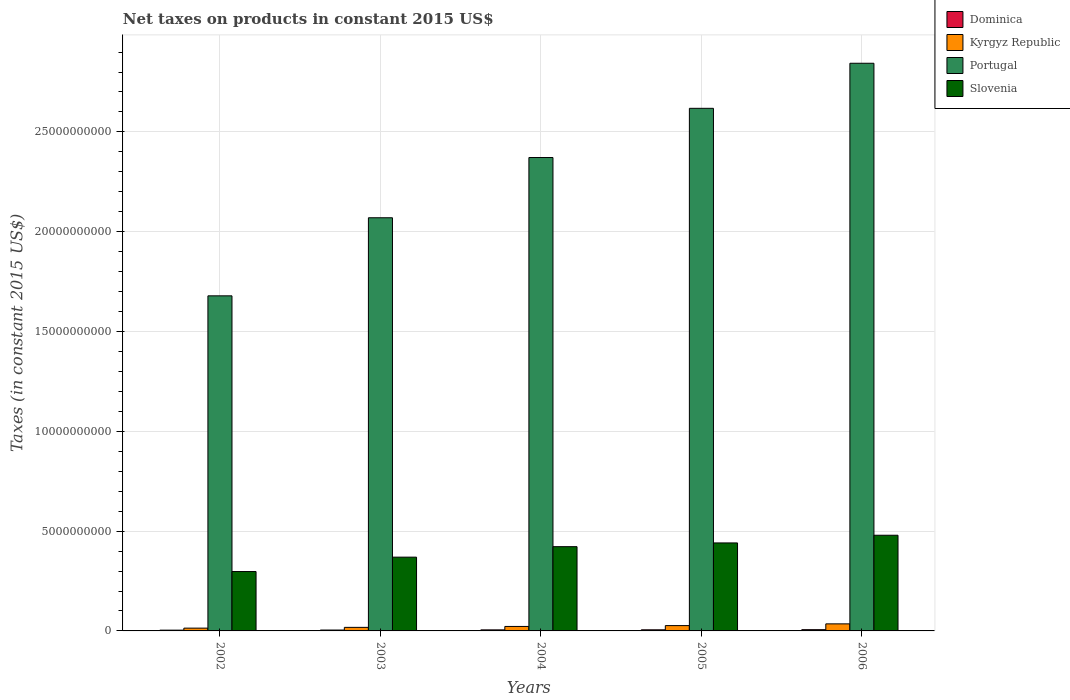How many different coloured bars are there?
Ensure brevity in your answer.  4. Are the number of bars per tick equal to the number of legend labels?
Offer a terse response. Yes. How many bars are there on the 2nd tick from the left?
Make the answer very short. 4. How many bars are there on the 5th tick from the right?
Ensure brevity in your answer.  4. What is the label of the 3rd group of bars from the left?
Your response must be concise. 2004. In how many cases, is the number of bars for a given year not equal to the number of legend labels?
Give a very brief answer. 0. What is the net taxes on products in Dominica in 2004?
Ensure brevity in your answer.  5.27e+07. Across all years, what is the maximum net taxes on products in Portugal?
Ensure brevity in your answer.  2.84e+1. Across all years, what is the minimum net taxes on products in Portugal?
Keep it short and to the point. 1.68e+1. What is the total net taxes on products in Slovenia in the graph?
Provide a succinct answer. 2.01e+1. What is the difference between the net taxes on products in Portugal in 2004 and that in 2005?
Offer a terse response. -2.47e+09. What is the difference between the net taxes on products in Slovenia in 2005 and the net taxes on products in Kyrgyz Republic in 2006?
Provide a short and direct response. 4.05e+09. What is the average net taxes on products in Dominica per year?
Give a very brief answer. 5.09e+07. In the year 2006, what is the difference between the net taxes on products in Dominica and net taxes on products in Slovenia?
Make the answer very short. -4.73e+09. In how many years, is the net taxes on products in Portugal greater than 2000000000 US$?
Offer a terse response. 5. What is the ratio of the net taxes on products in Slovenia in 2003 to that in 2006?
Offer a very short reply. 0.77. Is the net taxes on products in Kyrgyz Republic in 2003 less than that in 2006?
Your answer should be compact. Yes. Is the difference between the net taxes on products in Dominica in 2002 and 2004 greater than the difference between the net taxes on products in Slovenia in 2002 and 2004?
Offer a terse response. Yes. What is the difference between the highest and the second highest net taxes on products in Dominica?
Make the answer very short. 6.94e+06. What is the difference between the highest and the lowest net taxes on products in Dominica?
Give a very brief answer. 2.48e+07. Is the sum of the net taxes on products in Dominica in 2004 and 2005 greater than the maximum net taxes on products in Slovenia across all years?
Offer a terse response. No. What does the 2nd bar from the left in 2004 represents?
Give a very brief answer. Kyrgyz Republic. What does the 2nd bar from the right in 2005 represents?
Your answer should be compact. Portugal. How many bars are there?
Offer a terse response. 20. Are all the bars in the graph horizontal?
Make the answer very short. No. What is the difference between two consecutive major ticks on the Y-axis?
Your answer should be very brief. 5.00e+09. Does the graph contain grids?
Ensure brevity in your answer.  Yes. What is the title of the graph?
Your response must be concise. Net taxes on products in constant 2015 US$. What is the label or title of the X-axis?
Provide a short and direct response. Years. What is the label or title of the Y-axis?
Give a very brief answer. Taxes (in constant 2015 US$). What is the Taxes (in constant 2015 US$) in Dominica in 2002?
Offer a very short reply. 3.84e+07. What is the Taxes (in constant 2015 US$) of Kyrgyz Republic in 2002?
Give a very brief answer. 1.40e+08. What is the Taxes (in constant 2015 US$) of Portugal in 2002?
Make the answer very short. 1.68e+1. What is the Taxes (in constant 2015 US$) of Slovenia in 2002?
Give a very brief answer. 2.98e+09. What is the Taxes (in constant 2015 US$) of Dominica in 2003?
Offer a terse response. 4.41e+07. What is the Taxes (in constant 2015 US$) in Kyrgyz Republic in 2003?
Keep it short and to the point. 1.78e+08. What is the Taxes (in constant 2015 US$) in Portugal in 2003?
Your response must be concise. 2.07e+1. What is the Taxes (in constant 2015 US$) of Slovenia in 2003?
Offer a very short reply. 3.70e+09. What is the Taxes (in constant 2015 US$) of Dominica in 2004?
Offer a terse response. 5.27e+07. What is the Taxes (in constant 2015 US$) of Kyrgyz Republic in 2004?
Your response must be concise. 2.24e+08. What is the Taxes (in constant 2015 US$) of Portugal in 2004?
Your answer should be very brief. 2.37e+1. What is the Taxes (in constant 2015 US$) of Slovenia in 2004?
Give a very brief answer. 4.22e+09. What is the Taxes (in constant 2015 US$) of Dominica in 2005?
Offer a very short reply. 5.63e+07. What is the Taxes (in constant 2015 US$) in Kyrgyz Republic in 2005?
Your answer should be compact. 2.67e+08. What is the Taxes (in constant 2015 US$) of Portugal in 2005?
Give a very brief answer. 2.62e+1. What is the Taxes (in constant 2015 US$) in Slovenia in 2005?
Offer a very short reply. 4.41e+09. What is the Taxes (in constant 2015 US$) of Dominica in 2006?
Provide a short and direct response. 6.32e+07. What is the Taxes (in constant 2015 US$) in Kyrgyz Republic in 2006?
Your answer should be very brief. 3.54e+08. What is the Taxes (in constant 2015 US$) in Portugal in 2006?
Your answer should be compact. 2.84e+1. What is the Taxes (in constant 2015 US$) of Slovenia in 2006?
Your response must be concise. 4.79e+09. Across all years, what is the maximum Taxes (in constant 2015 US$) of Dominica?
Provide a succinct answer. 6.32e+07. Across all years, what is the maximum Taxes (in constant 2015 US$) in Kyrgyz Republic?
Give a very brief answer. 3.54e+08. Across all years, what is the maximum Taxes (in constant 2015 US$) in Portugal?
Offer a very short reply. 2.84e+1. Across all years, what is the maximum Taxes (in constant 2015 US$) of Slovenia?
Offer a terse response. 4.79e+09. Across all years, what is the minimum Taxes (in constant 2015 US$) in Dominica?
Your answer should be very brief. 3.84e+07. Across all years, what is the minimum Taxes (in constant 2015 US$) in Kyrgyz Republic?
Give a very brief answer. 1.40e+08. Across all years, what is the minimum Taxes (in constant 2015 US$) of Portugal?
Ensure brevity in your answer.  1.68e+1. Across all years, what is the minimum Taxes (in constant 2015 US$) of Slovenia?
Offer a very short reply. 2.98e+09. What is the total Taxes (in constant 2015 US$) in Dominica in the graph?
Your response must be concise. 2.55e+08. What is the total Taxes (in constant 2015 US$) in Kyrgyz Republic in the graph?
Offer a very short reply. 1.16e+09. What is the total Taxes (in constant 2015 US$) of Portugal in the graph?
Make the answer very short. 1.16e+11. What is the total Taxes (in constant 2015 US$) in Slovenia in the graph?
Keep it short and to the point. 2.01e+1. What is the difference between the Taxes (in constant 2015 US$) of Dominica in 2002 and that in 2003?
Ensure brevity in your answer.  -5.64e+06. What is the difference between the Taxes (in constant 2015 US$) of Kyrgyz Republic in 2002 and that in 2003?
Offer a terse response. -3.85e+07. What is the difference between the Taxes (in constant 2015 US$) of Portugal in 2002 and that in 2003?
Provide a succinct answer. -3.91e+09. What is the difference between the Taxes (in constant 2015 US$) of Slovenia in 2002 and that in 2003?
Offer a very short reply. -7.21e+08. What is the difference between the Taxes (in constant 2015 US$) in Dominica in 2002 and that in 2004?
Offer a very short reply. -1.43e+07. What is the difference between the Taxes (in constant 2015 US$) in Kyrgyz Republic in 2002 and that in 2004?
Keep it short and to the point. -8.43e+07. What is the difference between the Taxes (in constant 2015 US$) of Portugal in 2002 and that in 2004?
Your response must be concise. -6.93e+09. What is the difference between the Taxes (in constant 2015 US$) in Slovenia in 2002 and that in 2004?
Offer a terse response. -1.25e+09. What is the difference between the Taxes (in constant 2015 US$) in Dominica in 2002 and that in 2005?
Make the answer very short. -1.79e+07. What is the difference between the Taxes (in constant 2015 US$) in Kyrgyz Republic in 2002 and that in 2005?
Your response must be concise. -1.27e+08. What is the difference between the Taxes (in constant 2015 US$) of Portugal in 2002 and that in 2005?
Your answer should be very brief. -9.39e+09. What is the difference between the Taxes (in constant 2015 US$) in Slovenia in 2002 and that in 2005?
Provide a short and direct response. -1.43e+09. What is the difference between the Taxes (in constant 2015 US$) of Dominica in 2002 and that in 2006?
Keep it short and to the point. -2.48e+07. What is the difference between the Taxes (in constant 2015 US$) of Kyrgyz Republic in 2002 and that in 2006?
Provide a short and direct response. -2.14e+08. What is the difference between the Taxes (in constant 2015 US$) in Portugal in 2002 and that in 2006?
Offer a terse response. -1.17e+1. What is the difference between the Taxes (in constant 2015 US$) of Slovenia in 2002 and that in 2006?
Provide a short and direct response. -1.82e+09. What is the difference between the Taxes (in constant 2015 US$) of Dominica in 2003 and that in 2004?
Your answer should be very brief. -8.61e+06. What is the difference between the Taxes (in constant 2015 US$) of Kyrgyz Republic in 2003 and that in 2004?
Make the answer very short. -4.57e+07. What is the difference between the Taxes (in constant 2015 US$) in Portugal in 2003 and that in 2004?
Provide a succinct answer. -3.02e+09. What is the difference between the Taxes (in constant 2015 US$) of Slovenia in 2003 and that in 2004?
Offer a terse response. -5.26e+08. What is the difference between the Taxes (in constant 2015 US$) in Dominica in 2003 and that in 2005?
Keep it short and to the point. -1.22e+07. What is the difference between the Taxes (in constant 2015 US$) in Kyrgyz Republic in 2003 and that in 2005?
Your answer should be compact. -8.84e+07. What is the difference between the Taxes (in constant 2015 US$) of Portugal in 2003 and that in 2005?
Provide a short and direct response. -5.48e+09. What is the difference between the Taxes (in constant 2015 US$) of Slovenia in 2003 and that in 2005?
Give a very brief answer. -7.13e+08. What is the difference between the Taxes (in constant 2015 US$) in Dominica in 2003 and that in 2006?
Give a very brief answer. -1.92e+07. What is the difference between the Taxes (in constant 2015 US$) in Kyrgyz Republic in 2003 and that in 2006?
Your response must be concise. -1.75e+08. What is the difference between the Taxes (in constant 2015 US$) of Portugal in 2003 and that in 2006?
Provide a short and direct response. -7.74e+09. What is the difference between the Taxes (in constant 2015 US$) of Slovenia in 2003 and that in 2006?
Ensure brevity in your answer.  -1.10e+09. What is the difference between the Taxes (in constant 2015 US$) in Dominica in 2004 and that in 2005?
Provide a short and direct response. -3.61e+06. What is the difference between the Taxes (in constant 2015 US$) in Kyrgyz Republic in 2004 and that in 2005?
Keep it short and to the point. -4.27e+07. What is the difference between the Taxes (in constant 2015 US$) of Portugal in 2004 and that in 2005?
Offer a terse response. -2.47e+09. What is the difference between the Taxes (in constant 2015 US$) of Slovenia in 2004 and that in 2005?
Provide a short and direct response. -1.87e+08. What is the difference between the Taxes (in constant 2015 US$) of Dominica in 2004 and that in 2006?
Give a very brief answer. -1.06e+07. What is the difference between the Taxes (in constant 2015 US$) of Kyrgyz Republic in 2004 and that in 2006?
Ensure brevity in your answer.  -1.30e+08. What is the difference between the Taxes (in constant 2015 US$) in Portugal in 2004 and that in 2006?
Provide a succinct answer. -4.72e+09. What is the difference between the Taxes (in constant 2015 US$) in Slovenia in 2004 and that in 2006?
Keep it short and to the point. -5.72e+08. What is the difference between the Taxes (in constant 2015 US$) of Dominica in 2005 and that in 2006?
Your answer should be very brief. -6.94e+06. What is the difference between the Taxes (in constant 2015 US$) in Kyrgyz Republic in 2005 and that in 2006?
Your response must be concise. -8.70e+07. What is the difference between the Taxes (in constant 2015 US$) of Portugal in 2005 and that in 2006?
Provide a short and direct response. -2.26e+09. What is the difference between the Taxes (in constant 2015 US$) of Slovenia in 2005 and that in 2006?
Ensure brevity in your answer.  -3.85e+08. What is the difference between the Taxes (in constant 2015 US$) of Dominica in 2002 and the Taxes (in constant 2015 US$) of Kyrgyz Republic in 2003?
Your answer should be compact. -1.40e+08. What is the difference between the Taxes (in constant 2015 US$) of Dominica in 2002 and the Taxes (in constant 2015 US$) of Portugal in 2003?
Ensure brevity in your answer.  -2.07e+1. What is the difference between the Taxes (in constant 2015 US$) of Dominica in 2002 and the Taxes (in constant 2015 US$) of Slovenia in 2003?
Your answer should be very brief. -3.66e+09. What is the difference between the Taxes (in constant 2015 US$) of Kyrgyz Republic in 2002 and the Taxes (in constant 2015 US$) of Portugal in 2003?
Your response must be concise. -2.06e+1. What is the difference between the Taxes (in constant 2015 US$) of Kyrgyz Republic in 2002 and the Taxes (in constant 2015 US$) of Slovenia in 2003?
Make the answer very short. -3.56e+09. What is the difference between the Taxes (in constant 2015 US$) in Portugal in 2002 and the Taxes (in constant 2015 US$) in Slovenia in 2003?
Your answer should be very brief. 1.31e+1. What is the difference between the Taxes (in constant 2015 US$) of Dominica in 2002 and the Taxes (in constant 2015 US$) of Kyrgyz Republic in 2004?
Give a very brief answer. -1.85e+08. What is the difference between the Taxes (in constant 2015 US$) of Dominica in 2002 and the Taxes (in constant 2015 US$) of Portugal in 2004?
Ensure brevity in your answer.  -2.37e+1. What is the difference between the Taxes (in constant 2015 US$) of Dominica in 2002 and the Taxes (in constant 2015 US$) of Slovenia in 2004?
Keep it short and to the point. -4.18e+09. What is the difference between the Taxes (in constant 2015 US$) in Kyrgyz Republic in 2002 and the Taxes (in constant 2015 US$) in Portugal in 2004?
Ensure brevity in your answer.  -2.36e+1. What is the difference between the Taxes (in constant 2015 US$) in Kyrgyz Republic in 2002 and the Taxes (in constant 2015 US$) in Slovenia in 2004?
Ensure brevity in your answer.  -4.08e+09. What is the difference between the Taxes (in constant 2015 US$) in Portugal in 2002 and the Taxes (in constant 2015 US$) in Slovenia in 2004?
Provide a short and direct response. 1.26e+1. What is the difference between the Taxes (in constant 2015 US$) in Dominica in 2002 and the Taxes (in constant 2015 US$) in Kyrgyz Republic in 2005?
Your answer should be very brief. -2.28e+08. What is the difference between the Taxes (in constant 2015 US$) of Dominica in 2002 and the Taxes (in constant 2015 US$) of Portugal in 2005?
Offer a terse response. -2.61e+1. What is the difference between the Taxes (in constant 2015 US$) in Dominica in 2002 and the Taxes (in constant 2015 US$) in Slovenia in 2005?
Your answer should be compact. -4.37e+09. What is the difference between the Taxes (in constant 2015 US$) in Kyrgyz Republic in 2002 and the Taxes (in constant 2015 US$) in Portugal in 2005?
Ensure brevity in your answer.  -2.60e+1. What is the difference between the Taxes (in constant 2015 US$) of Kyrgyz Republic in 2002 and the Taxes (in constant 2015 US$) of Slovenia in 2005?
Keep it short and to the point. -4.27e+09. What is the difference between the Taxes (in constant 2015 US$) of Portugal in 2002 and the Taxes (in constant 2015 US$) of Slovenia in 2005?
Your answer should be compact. 1.24e+1. What is the difference between the Taxes (in constant 2015 US$) of Dominica in 2002 and the Taxes (in constant 2015 US$) of Kyrgyz Republic in 2006?
Offer a very short reply. -3.15e+08. What is the difference between the Taxes (in constant 2015 US$) of Dominica in 2002 and the Taxes (in constant 2015 US$) of Portugal in 2006?
Your answer should be very brief. -2.84e+1. What is the difference between the Taxes (in constant 2015 US$) in Dominica in 2002 and the Taxes (in constant 2015 US$) in Slovenia in 2006?
Your answer should be very brief. -4.75e+09. What is the difference between the Taxes (in constant 2015 US$) in Kyrgyz Republic in 2002 and the Taxes (in constant 2015 US$) in Portugal in 2006?
Your response must be concise. -2.83e+1. What is the difference between the Taxes (in constant 2015 US$) of Kyrgyz Republic in 2002 and the Taxes (in constant 2015 US$) of Slovenia in 2006?
Offer a very short reply. -4.65e+09. What is the difference between the Taxes (in constant 2015 US$) of Portugal in 2002 and the Taxes (in constant 2015 US$) of Slovenia in 2006?
Offer a terse response. 1.20e+1. What is the difference between the Taxes (in constant 2015 US$) of Dominica in 2003 and the Taxes (in constant 2015 US$) of Kyrgyz Republic in 2004?
Offer a terse response. -1.80e+08. What is the difference between the Taxes (in constant 2015 US$) in Dominica in 2003 and the Taxes (in constant 2015 US$) in Portugal in 2004?
Your answer should be compact. -2.37e+1. What is the difference between the Taxes (in constant 2015 US$) of Dominica in 2003 and the Taxes (in constant 2015 US$) of Slovenia in 2004?
Your answer should be compact. -4.18e+09. What is the difference between the Taxes (in constant 2015 US$) of Kyrgyz Republic in 2003 and the Taxes (in constant 2015 US$) of Portugal in 2004?
Ensure brevity in your answer.  -2.35e+1. What is the difference between the Taxes (in constant 2015 US$) in Kyrgyz Republic in 2003 and the Taxes (in constant 2015 US$) in Slovenia in 2004?
Offer a very short reply. -4.04e+09. What is the difference between the Taxes (in constant 2015 US$) of Portugal in 2003 and the Taxes (in constant 2015 US$) of Slovenia in 2004?
Ensure brevity in your answer.  1.65e+1. What is the difference between the Taxes (in constant 2015 US$) in Dominica in 2003 and the Taxes (in constant 2015 US$) in Kyrgyz Republic in 2005?
Ensure brevity in your answer.  -2.23e+08. What is the difference between the Taxes (in constant 2015 US$) of Dominica in 2003 and the Taxes (in constant 2015 US$) of Portugal in 2005?
Offer a very short reply. -2.61e+1. What is the difference between the Taxes (in constant 2015 US$) in Dominica in 2003 and the Taxes (in constant 2015 US$) in Slovenia in 2005?
Offer a very short reply. -4.36e+09. What is the difference between the Taxes (in constant 2015 US$) in Kyrgyz Republic in 2003 and the Taxes (in constant 2015 US$) in Portugal in 2005?
Provide a short and direct response. -2.60e+1. What is the difference between the Taxes (in constant 2015 US$) in Kyrgyz Republic in 2003 and the Taxes (in constant 2015 US$) in Slovenia in 2005?
Offer a very short reply. -4.23e+09. What is the difference between the Taxes (in constant 2015 US$) of Portugal in 2003 and the Taxes (in constant 2015 US$) of Slovenia in 2005?
Make the answer very short. 1.63e+1. What is the difference between the Taxes (in constant 2015 US$) of Dominica in 2003 and the Taxes (in constant 2015 US$) of Kyrgyz Republic in 2006?
Offer a very short reply. -3.10e+08. What is the difference between the Taxes (in constant 2015 US$) of Dominica in 2003 and the Taxes (in constant 2015 US$) of Portugal in 2006?
Give a very brief answer. -2.84e+1. What is the difference between the Taxes (in constant 2015 US$) in Dominica in 2003 and the Taxes (in constant 2015 US$) in Slovenia in 2006?
Your answer should be very brief. -4.75e+09. What is the difference between the Taxes (in constant 2015 US$) of Kyrgyz Republic in 2003 and the Taxes (in constant 2015 US$) of Portugal in 2006?
Your answer should be compact. -2.83e+1. What is the difference between the Taxes (in constant 2015 US$) of Kyrgyz Republic in 2003 and the Taxes (in constant 2015 US$) of Slovenia in 2006?
Offer a terse response. -4.62e+09. What is the difference between the Taxes (in constant 2015 US$) of Portugal in 2003 and the Taxes (in constant 2015 US$) of Slovenia in 2006?
Provide a short and direct response. 1.59e+1. What is the difference between the Taxes (in constant 2015 US$) in Dominica in 2004 and the Taxes (in constant 2015 US$) in Kyrgyz Republic in 2005?
Offer a very short reply. -2.14e+08. What is the difference between the Taxes (in constant 2015 US$) in Dominica in 2004 and the Taxes (in constant 2015 US$) in Portugal in 2005?
Your answer should be compact. -2.61e+1. What is the difference between the Taxes (in constant 2015 US$) of Dominica in 2004 and the Taxes (in constant 2015 US$) of Slovenia in 2005?
Offer a very short reply. -4.36e+09. What is the difference between the Taxes (in constant 2015 US$) in Kyrgyz Republic in 2004 and the Taxes (in constant 2015 US$) in Portugal in 2005?
Your response must be concise. -2.60e+1. What is the difference between the Taxes (in constant 2015 US$) in Kyrgyz Republic in 2004 and the Taxes (in constant 2015 US$) in Slovenia in 2005?
Provide a succinct answer. -4.18e+09. What is the difference between the Taxes (in constant 2015 US$) in Portugal in 2004 and the Taxes (in constant 2015 US$) in Slovenia in 2005?
Offer a terse response. 1.93e+1. What is the difference between the Taxes (in constant 2015 US$) of Dominica in 2004 and the Taxes (in constant 2015 US$) of Kyrgyz Republic in 2006?
Your answer should be compact. -3.01e+08. What is the difference between the Taxes (in constant 2015 US$) in Dominica in 2004 and the Taxes (in constant 2015 US$) in Portugal in 2006?
Give a very brief answer. -2.84e+1. What is the difference between the Taxes (in constant 2015 US$) in Dominica in 2004 and the Taxes (in constant 2015 US$) in Slovenia in 2006?
Your answer should be compact. -4.74e+09. What is the difference between the Taxes (in constant 2015 US$) of Kyrgyz Republic in 2004 and the Taxes (in constant 2015 US$) of Portugal in 2006?
Your answer should be very brief. -2.82e+1. What is the difference between the Taxes (in constant 2015 US$) in Kyrgyz Republic in 2004 and the Taxes (in constant 2015 US$) in Slovenia in 2006?
Make the answer very short. -4.57e+09. What is the difference between the Taxes (in constant 2015 US$) of Portugal in 2004 and the Taxes (in constant 2015 US$) of Slovenia in 2006?
Your response must be concise. 1.89e+1. What is the difference between the Taxes (in constant 2015 US$) of Dominica in 2005 and the Taxes (in constant 2015 US$) of Kyrgyz Republic in 2006?
Your answer should be compact. -2.97e+08. What is the difference between the Taxes (in constant 2015 US$) of Dominica in 2005 and the Taxes (in constant 2015 US$) of Portugal in 2006?
Give a very brief answer. -2.84e+1. What is the difference between the Taxes (in constant 2015 US$) in Dominica in 2005 and the Taxes (in constant 2015 US$) in Slovenia in 2006?
Provide a short and direct response. -4.74e+09. What is the difference between the Taxes (in constant 2015 US$) of Kyrgyz Republic in 2005 and the Taxes (in constant 2015 US$) of Portugal in 2006?
Your answer should be compact. -2.82e+1. What is the difference between the Taxes (in constant 2015 US$) in Kyrgyz Republic in 2005 and the Taxes (in constant 2015 US$) in Slovenia in 2006?
Offer a terse response. -4.53e+09. What is the difference between the Taxes (in constant 2015 US$) in Portugal in 2005 and the Taxes (in constant 2015 US$) in Slovenia in 2006?
Make the answer very short. 2.14e+1. What is the average Taxes (in constant 2015 US$) of Dominica per year?
Make the answer very short. 5.09e+07. What is the average Taxes (in constant 2015 US$) of Kyrgyz Republic per year?
Make the answer very short. 2.32e+08. What is the average Taxes (in constant 2015 US$) of Portugal per year?
Provide a short and direct response. 2.32e+1. What is the average Taxes (in constant 2015 US$) of Slovenia per year?
Give a very brief answer. 4.02e+09. In the year 2002, what is the difference between the Taxes (in constant 2015 US$) of Dominica and Taxes (in constant 2015 US$) of Kyrgyz Republic?
Offer a terse response. -1.01e+08. In the year 2002, what is the difference between the Taxes (in constant 2015 US$) in Dominica and Taxes (in constant 2015 US$) in Portugal?
Give a very brief answer. -1.67e+1. In the year 2002, what is the difference between the Taxes (in constant 2015 US$) of Dominica and Taxes (in constant 2015 US$) of Slovenia?
Your response must be concise. -2.94e+09. In the year 2002, what is the difference between the Taxes (in constant 2015 US$) of Kyrgyz Republic and Taxes (in constant 2015 US$) of Portugal?
Your response must be concise. -1.66e+1. In the year 2002, what is the difference between the Taxes (in constant 2015 US$) in Kyrgyz Republic and Taxes (in constant 2015 US$) in Slovenia?
Keep it short and to the point. -2.84e+09. In the year 2002, what is the difference between the Taxes (in constant 2015 US$) of Portugal and Taxes (in constant 2015 US$) of Slovenia?
Give a very brief answer. 1.38e+1. In the year 2003, what is the difference between the Taxes (in constant 2015 US$) in Dominica and Taxes (in constant 2015 US$) in Kyrgyz Republic?
Your response must be concise. -1.34e+08. In the year 2003, what is the difference between the Taxes (in constant 2015 US$) of Dominica and Taxes (in constant 2015 US$) of Portugal?
Ensure brevity in your answer.  -2.07e+1. In the year 2003, what is the difference between the Taxes (in constant 2015 US$) of Dominica and Taxes (in constant 2015 US$) of Slovenia?
Offer a very short reply. -3.65e+09. In the year 2003, what is the difference between the Taxes (in constant 2015 US$) of Kyrgyz Republic and Taxes (in constant 2015 US$) of Portugal?
Keep it short and to the point. -2.05e+1. In the year 2003, what is the difference between the Taxes (in constant 2015 US$) in Kyrgyz Republic and Taxes (in constant 2015 US$) in Slovenia?
Keep it short and to the point. -3.52e+09. In the year 2003, what is the difference between the Taxes (in constant 2015 US$) in Portugal and Taxes (in constant 2015 US$) in Slovenia?
Provide a succinct answer. 1.70e+1. In the year 2004, what is the difference between the Taxes (in constant 2015 US$) of Dominica and Taxes (in constant 2015 US$) of Kyrgyz Republic?
Give a very brief answer. -1.71e+08. In the year 2004, what is the difference between the Taxes (in constant 2015 US$) of Dominica and Taxes (in constant 2015 US$) of Portugal?
Your answer should be very brief. -2.37e+1. In the year 2004, what is the difference between the Taxes (in constant 2015 US$) of Dominica and Taxes (in constant 2015 US$) of Slovenia?
Give a very brief answer. -4.17e+09. In the year 2004, what is the difference between the Taxes (in constant 2015 US$) in Kyrgyz Republic and Taxes (in constant 2015 US$) in Portugal?
Keep it short and to the point. -2.35e+1. In the year 2004, what is the difference between the Taxes (in constant 2015 US$) of Kyrgyz Republic and Taxes (in constant 2015 US$) of Slovenia?
Make the answer very short. -4.00e+09. In the year 2004, what is the difference between the Taxes (in constant 2015 US$) in Portugal and Taxes (in constant 2015 US$) in Slovenia?
Your answer should be compact. 1.95e+1. In the year 2005, what is the difference between the Taxes (in constant 2015 US$) of Dominica and Taxes (in constant 2015 US$) of Kyrgyz Republic?
Provide a succinct answer. -2.10e+08. In the year 2005, what is the difference between the Taxes (in constant 2015 US$) in Dominica and Taxes (in constant 2015 US$) in Portugal?
Make the answer very short. -2.61e+1. In the year 2005, what is the difference between the Taxes (in constant 2015 US$) of Dominica and Taxes (in constant 2015 US$) of Slovenia?
Provide a succinct answer. -4.35e+09. In the year 2005, what is the difference between the Taxes (in constant 2015 US$) in Kyrgyz Republic and Taxes (in constant 2015 US$) in Portugal?
Your response must be concise. -2.59e+1. In the year 2005, what is the difference between the Taxes (in constant 2015 US$) of Kyrgyz Republic and Taxes (in constant 2015 US$) of Slovenia?
Your answer should be very brief. -4.14e+09. In the year 2005, what is the difference between the Taxes (in constant 2015 US$) of Portugal and Taxes (in constant 2015 US$) of Slovenia?
Your answer should be very brief. 2.18e+1. In the year 2006, what is the difference between the Taxes (in constant 2015 US$) of Dominica and Taxes (in constant 2015 US$) of Kyrgyz Republic?
Provide a short and direct response. -2.90e+08. In the year 2006, what is the difference between the Taxes (in constant 2015 US$) in Dominica and Taxes (in constant 2015 US$) in Portugal?
Offer a very short reply. -2.84e+1. In the year 2006, what is the difference between the Taxes (in constant 2015 US$) in Dominica and Taxes (in constant 2015 US$) in Slovenia?
Make the answer very short. -4.73e+09. In the year 2006, what is the difference between the Taxes (in constant 2015 US$) in Kyrgyz Republic and Taxes (in constant 2015 US$) in Portugal?
Provide a succinct answer. -2.81e+1. In the year 2006, what is the difference between the Taxes (in constant 2015 US$) of Kyrgyz Republic and Taxes (in constant 2015 US$) of Slovenia?
Ensure brevity in your answer.  -4.44e+09. In the year 2006, what is the difference between the Taxes (in constant 2015 US$) of Portugal and Taxes (in constant 2015 US$) of Slovenia?
Your response must be concise. 2.36e+1. What is the ratio of the Taxes (in constant 2015 US$) of Dominica in 2002 to that in 2003?
Ensure brevity in your answer.  0.87. What is the ratio of the Taxes (in constant 2015 US$) of Kyrgyz Republic in 2002 to that in 2003?
Your answer should be very brief. 0.78. What is the ratio of the Taxes (in constant 2015 US$) in Portugal in 2002 to that in 2003?
Make the answer very short. 0.81. What is the ratio of the Taxes (in constant 2015 US$) of Slovenia in 2002 to that in 2003?
Give a very brief answer. 0.81. What is the ratio of the Taxes (in constant 2015 US$) of Dominica in 2002 to that in 2004?
Give a very brief answer. 0.73. What is the ratio of the Taxes (in constant 2015 US$) in Kyrgyz Republic in 2002 to that in 2004?
Provide a short and direct response. 0.62. What is the ratio of the Taxes (in constant 2015 US$) in Portugal in 2002 to that in 2004?
Give a very brief answer. 0.71. What is the ratio of the Taxes (in constant 2015 US$) in Slovenia in 2002 to that in 2004?
Offer a terse response. 0.7. What is the ratio of the Taxes (in constant 2015 US$) of Dominica in 2002 to that in 2005?
Ensure brevity in your answer.  0.68. What is the ratio of the Taxes (in constant 2015 US$) of Kyrgyz Republic in 2002 to that in 2005?
Your response must be concise. 0.52. What is the ratio of the Taxes (in constant 2015 US$) of Portugal in 2002 to that in 2005?
Your answer should be compact. 0.64. What is the ratio of the Taxes (in constant 2015 US$) in Slovenia in 2002 to that in 2005?
Give a very brief answer. 0.67. What is the ratio of the Taxes (in constant 2015 US$) of Dominica in 2002 to that in 2006?
Your response must be concise. 0.61. What is the ratio of the Taxes (in constant 2015 US$) of Kyrgyz Republic in 2002 to that in 2006?
Ensure brevity in your answer.  0.39. What is the ratio of the Taxes (in constant 2015 US$) in Portugal in 2002 to that in 2006?
Ensure brevity in your answer.  0.59. What is the ratio of the Taxes (in constant 2015 US$) in Slovenia in 2002 to that in 2006?
Offer a very short reply. 0.62. What is the ratio of the Taxes (in constant 2015 US$) in Dominica in 2003 to that in 2004?
Offer a terse response. 0.84. What is the ratio of the Taxes (in constant 2015 US$) in Kyrgyz Republic in 2003 to that in 2004?
Your answer should be compact. 0.8. What is the ratio of the Taxes (in constant 2015 US$) in Portugal in 2003 to that in 2004?
Offer a very short reply. 0.87. What is the ratio of the Taxes (in constant 2015 US$) of Slovenia in 2003 to that in 2004?
Make the answer very short. 0.88. What is the ratio of the Taxes (in constant 2015 US$) in Dominica in 2003 to that in 2005?
Ensure brevity in your answer.  0.78. What is the ratio of the Taxes (in constant 2015 US$) of Kyrgyz Republic in 2003 to that in 2005?
Your answer should be very brief. 0.67. What is the ratio of the Taxes (in constant 2015 US$) of Portugal in 2003 to that in 2005?
Offer a very short reply. 0.79. What is the ratio of the Taxes (in constant 2015 US$) of Slovenia in 2003 to that in 2005?
Offer a terse response. 0.84. What is the ratio of the Taxes (in constant 2015 US$) in Dominica in 2003 to that in 2006?
Keep it short and to the point. 0.7. What is the ratio of the Taxes (in constant 2015 US$) of Kyrgyz Republic in 2003 to that in 2006?
Offer a very short reply. 0.5. What is the ratio of the Taxes (in constant 2015 US$) in Portugal in 2003 to that in 2006?
Provide a short and direct response. 0.73. What is the ratio of the Taxes (in constant 2015 US$) in Slovenia in 2003 to that in 2006?
Your answer should be very brief. 0.77. What is the ratio of the Taxes (in constant 2015 US$) of Dominica in 2004 to that in 2005?
Provide a short and direct response. 0.94. What is the ratio of the Taxes (in constant 2015 US$) in Kyrgyz Republic in 2004 to that in 2005?
Your answer should be compact. 0.84. What is the ratio of the Taxes (in constant 2015 US$) of Portugal in 2004 to that in 2005?
Provide a succinct answer. 0.91. What is the ratio of the Taxes (in constant 2015 US$) in Slovenia in 2004 to that in 2005?
Make the answer very short. 0.96. What is the ratio of the Taxes (in constant 2015 US$) of Dominica in 2004 to that in 2006?
Your answer should be compact. 0.83. What is the ratio of the Taxes (in constant 2015 US$) in Kyrgyz Republic in 2004 to that in 2006?
Give a very brief answer. 0.63. What is the ratio of the Taxes (in constant 2015 US$) of Portugal in 2004 to that in 2006?
Offer a very short reply. 0.83. What is the ratio of the Taxes (in constant 2015 US$) in Slovenia in 2004 to that in 2006?
Offer a very short reply. 0.88. What is the ratio of the Taxes (in constant 2015 US$) of Dominica in 2005 to that in 2006?
Ensure brevity in your answer.  0.89. What is the ratio of the Taxes (in constant 2015 US$) of Kyrgyz Republic in 2005 to that in 2006?
Provide a short and direct response. 0.75. What is the ratio of the Taxes (in constant 2015 US$) in Portugal in 2005 to that in 2006?
Your answer should be very brief. 0.92. What is the ratio of the Taxes (in constant 2015 US$) of Slovenia in 2005 to that in 2006?
Your answer should be very brief. 0.92. What is the difference between the highest and the second highest Taxes (in constant 2015 US$) of Dominica?
Give a very brief answer. 6.94e+06. What is the difference between the highest and the second highest Taxes (in constant 2015 US$) of Kyrgyz Republic?
Your answer should be very brief. 8.70e+07. What is the difference between the highest and the second highest Taxes (in constant 2015 US$) in Portugal?
Provide a succinct answer. 2.26e+09. What is the difference between the highest and the second highest Taxes (in constant 2015 US$) of Slovenia?
Give a very brief answer. 3.85e+08. What is the difference between the highest and the lowest Taxes (in constant 2015 US$) in Dominica?
Provide a short and direct response. 2.48e+07. What is the difference between the highest and the lowest Taxes (in constant 2015 US$) in Kyrgyz Republic?
Keep it short and to the point. 2.14e+08. What is the difference between the highest and the lowest Taxes (in constant 2015 US$) in Portugal?
Ensure brevity in your answer.  1.17e+1. What is the difference between the highest and the lowest Taxes (in constant 2015 US$) of Slovenia?
Your answer should be compact. 1.82e+09. 